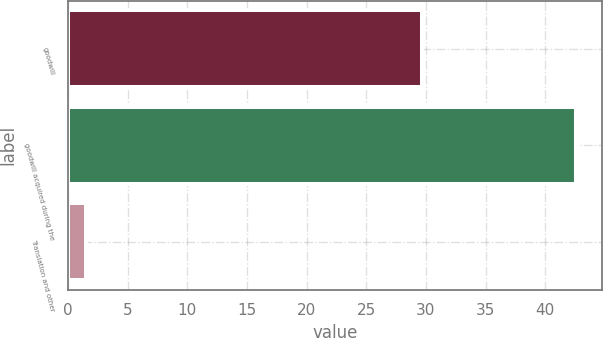Convert chart to OTSL. <chart><loc_0><loc_0><loc_500><loc_500><bar_chart><fcel>goodwill<fcel>goodwill acquired during the<fcel>Translation and other<nl><fcel>29.7<fcel>42.6<fcel>1.5<nl></chart> 